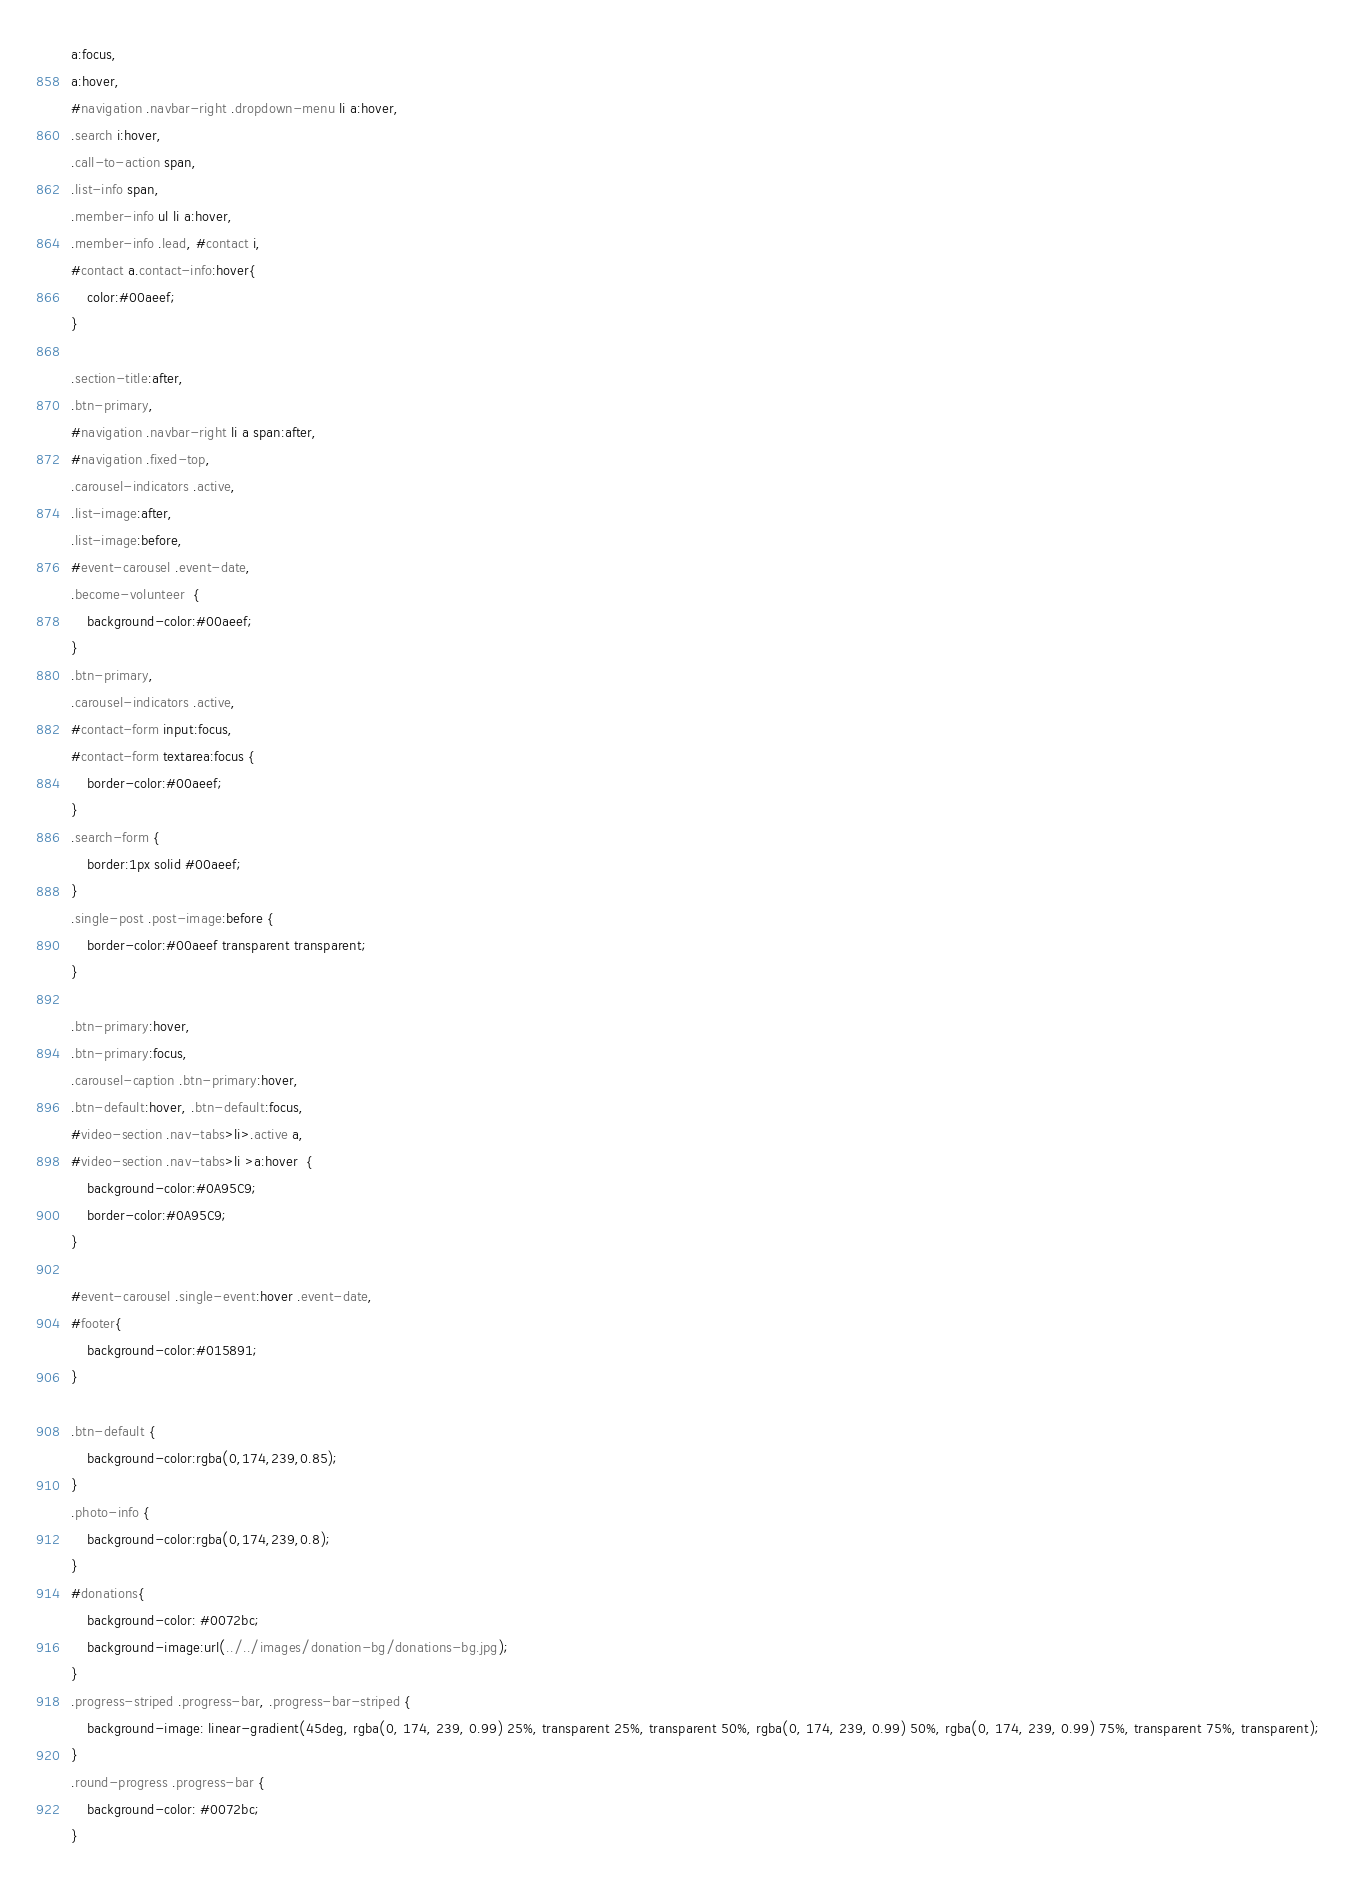<code> <loc_0><loc_0><loc_500><loc_500><_CSS_>a:focus, 
a:hover, 
#navigation .navbar-right .dropdown-menu li a:hover, 
.search i:hover, 
.call-to-action span, 
.list-info span, 
.member-info ul li a:hover, 
.member-info .lead, #contact i, 
#contact a.contact-info:hover{	
	color:#00aeef;
}

.section-title:after, 
.btn-primary, 
#navigation .navbar-right li a span:after, 
#navigation .fixed-top, 
.carousel-indicators .active, 
.list-image:after, 
.list-image:before, 
#event-carousel .event-date, 
.become-volunteer  {	
	background-color:#00aeef;	
}
.btn-primary, 
.carousel-indicators .active, 
#contact-form input:focus, 
#contact-form textarea:focus {
	border-color:#00aeef;
}
.search-form {
	border:1px solid #00aeef;
}
.single-post .post-image:before {
	border-color:#00aeef transparent transparent;
}

.btn-primary:hover, 
.btn-primary:focus, 
.carousel-caption .btn-primary:hover,
.btn-default:hover, .btn-default:focus, 
#video-section .nav-tabs>li>.active a, 
#video-section .nav-tabs>li >a:hover  {
	background-color:#0A95C9;
	border-color:#0A95C9;
}

#event-carousel .single-event:hover .event-date, 
#footer{
	background-color:#015891;
}

.btn-default {
	background-color:rgba(0,174,239,0.85);
}
.photo-info {
	background-color:rgba(0,174,239,0.8);
}
#donations{
	background-color: #0072bc;
	background-image:url(../../images/donation-bg/donations-bg.jpg);	
}
.progress-striped .progress-bar, .progress-bar-striped {
	background-image: linear-gradient(45deg, rgba(0, 174, 239, 0.99) 25%, transparent 25%, transparent 50%, rgba(0, 174, 239, 0.99) 50%, rgba(0, 174, 239, 0.99) 75%, transparent 75%, transparent);
}
.round-progress .progress-bar {
	background-color: #0072bc; 
}</code> 